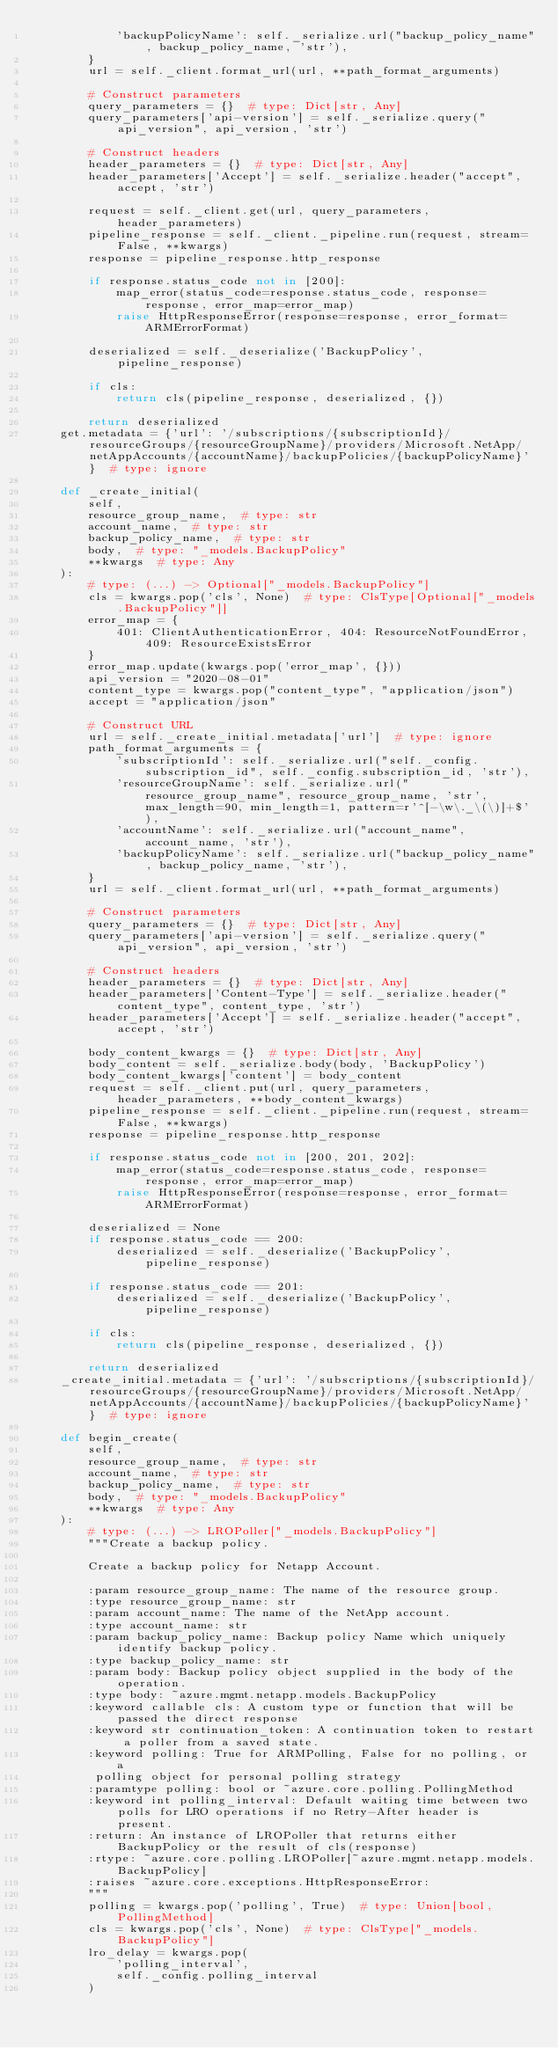<code> <loc_0><loc_0><loc_500><loc_500><_Python_>            'backupPolicyName': self._serialize.url("backup_policy_name", backup_policy_name, 'str'),
        }
        url = self._client.format_url(url, **path_format_arguments)

        # Construct parameters
        query_parameters = {}  # type: Dict[str, Any]
        query_parameters['api-version'] = self._serialize.query("api_version", api_version, 'str')

        # Construct headers
        header_parameters = {}  # type: Dict[str, Any]
        header_parameters['Accept'] = self._serialize.header("accept", accept, 'str')

        request = self._client.get(url, query_parameters, header_parameters)
        pipeline_response = self._client._pipeline.run(request, stream=False, **kwargs)
        response = pipeline_response.http_response

        if response.status_code not in [200]:
            map_error(status_code=response.status_code, response=response, error_map=error_map)
            raise HttpResponseError(response=response, error_format=ARMErrorFormat)

        deserialized = self._deserialize('BackupPolicy', pipeline_response)

        if cls:
            return cls(pipeline_response, deserialized, {})

        return deserialized
    get.metadata = {'url': '/subscriptions/{subscriptionId}/resourceGroups/{resourceGroupName}/providers/Microsoft.NetApp/netAppAccounts/{accountName}/backupPolicies/{backupPolicyName}'}  # type: ignore

    def _create_initial(
        self,
        resource_group_name,  # type: str
        account_name,  # type: str
        backup_policy_name,  # type: str
        body,  # type: "_models.BackupPolicy"
        **kwargs  # type: Any
    ):
        # type: (...) -> Optional["_models.BackupPolicy"]
        cls = kwargs.pop('cls', None)  # type: ClsType[Optional["_models.BackupPolicy"]]
        error_map = {
            401: ClientAuthenticationError, 404: ResourceNotFoundError, 409: ResourceExistsError
        }
        error_map.update(kwargs.pop('error_map', {}))
        api_version = "2020-08-01"
        content_type = kwargs.pop("content_type", "application/json")
        accept = "application/json"

        # Construct URL
        url = self._create_initial.metadata['url']  # type: ignore
        path_format_arguments = {
            'subscriptionId': self._serialize.url("self._config.subscription_id", self._config.subscription_id, 'str'),
            'resourceGroupName': self._serialize.url("resource_group_name", resource_group_name, 'str', max_length=90, min_length=1, pattern=r'^[-\w\._\(\)]+$'),
            'accountName': self._serialize.url("account_name", account_name, 'str'),
            'backupPolicyName': self._serialize.url("backup_policy_name", backup_policy_name, 'str'),
        }
        url = self._client.format_url(url, **path_format_arguments)

        # Construct parameters
        query_parameters = {}  # type: Dict[str, Any]
        query_parameters['api-version'] = self._serialize.query("api_version", api_version, 'str')

        # Construct headers
        header_parameters = {}  # type: Dict[str, Any]
        header_parameters['Content-Type'] = self._serialize.header("content_type", content_type, 'str')
        header_parameters['Accept'] = self._serialize.header("accept", accept, 'str')

        body_content_kwargs = {}  # type: Dict[str, Any]
        body_content = self._serialize.body(body, 'BackupPolicy')
        body_content_kwargs['content'] = body_content
        request = self._client.put(url, query_parameters, header_parameters, **body_content_kwargs)
        pipeline_response = self._client._pipeline.run(request, stream=False, **kwargs)
        response = pipeline_response.http_response

        if response.status_code not in [200, 201, 202]:
            map_error(status_code=response.status_code, response=response, error_map=error_map)
            raise HttpResponseError(response=response, error_format=ARMErrorFormat)

        deserialized = None
        if response.status_code == 200:
            deserialized = self._deserialize('BackupPolicy', pipeline_response)

        if response.status_code == 201:
            deserialized = self._deserialize('BackupPolicy', pipeline_response)

        if cls:
            return cls(pipeline_response, deserialized, {})

        return deserialized
    _create_initial.metadata = {'url': '/subscriptions/{subscriptionId}/resourceGroups/{resourceGroupName}/providers/Microsoft.NetApp/netAppAccounts/{accountName}/backupPolicies/{backupPolicyName}'}  # type: ignore

    def begin_create(
        self,
        resource_group_name,  # type: str
        account_name,  # type: str
        backup_policy_name,  # type: str
        body,  # type: "_models.BackupPolicy"
        **kwargs  # type: Any
    ):
        # type: (...) -> LROPoller["_models.BackupPolicy"]
        """Create a backup policy.

        Create a backup policy for Netapp Account.

        :param resource_group_name: The name of the resource group.
        :type resource_group_name: str
        :param account_name: The name of the NetApp account.
        :type account_name: str
        :param backup_policy_name: Backup policy Name which uniquely identify backup policy.
        :type backup_policy_name: str
        :param body: Backup policy object supplied in the body of the operation.
        :type body: ~azure.mgmt.netapp.models.BackupPolicy
        :keyword callable cls: A custom type or function that will be passed the direct response
        :keyword str continuation_token: A continuation token to restart a poller from a saved state.
        :keyword polling: True for ARMPolling, False for no polling, or a
         polling object for personal polling strategy
        :paramtype polling: bool or ~azure.core.polling.PollingMethod
        :keyword int polling_interval: Default waiting time between two polls for LRO operations if no Retry-After header is present.
        :return: An instance of LROPoller that returns either BackupPolicy or the result of cls(response)
        :rtype: ~azure.core.polling.LROPoller[~azure.mgmt.netapp.models.BackupPolicy]
        :raises ~azure.core.exceptions.HttpResponseError:
        """
        polling = kwargs.pop('polling', True)  # type: Union[bool, PollingMethod]
        cls = kwargs.pop('cls', None)  # type: ClsType["_models.BackupPolicy"]
        lro_delay = kwargs.pop(
            'polling_interval',
            self._config.polling_interval
        )</code> 